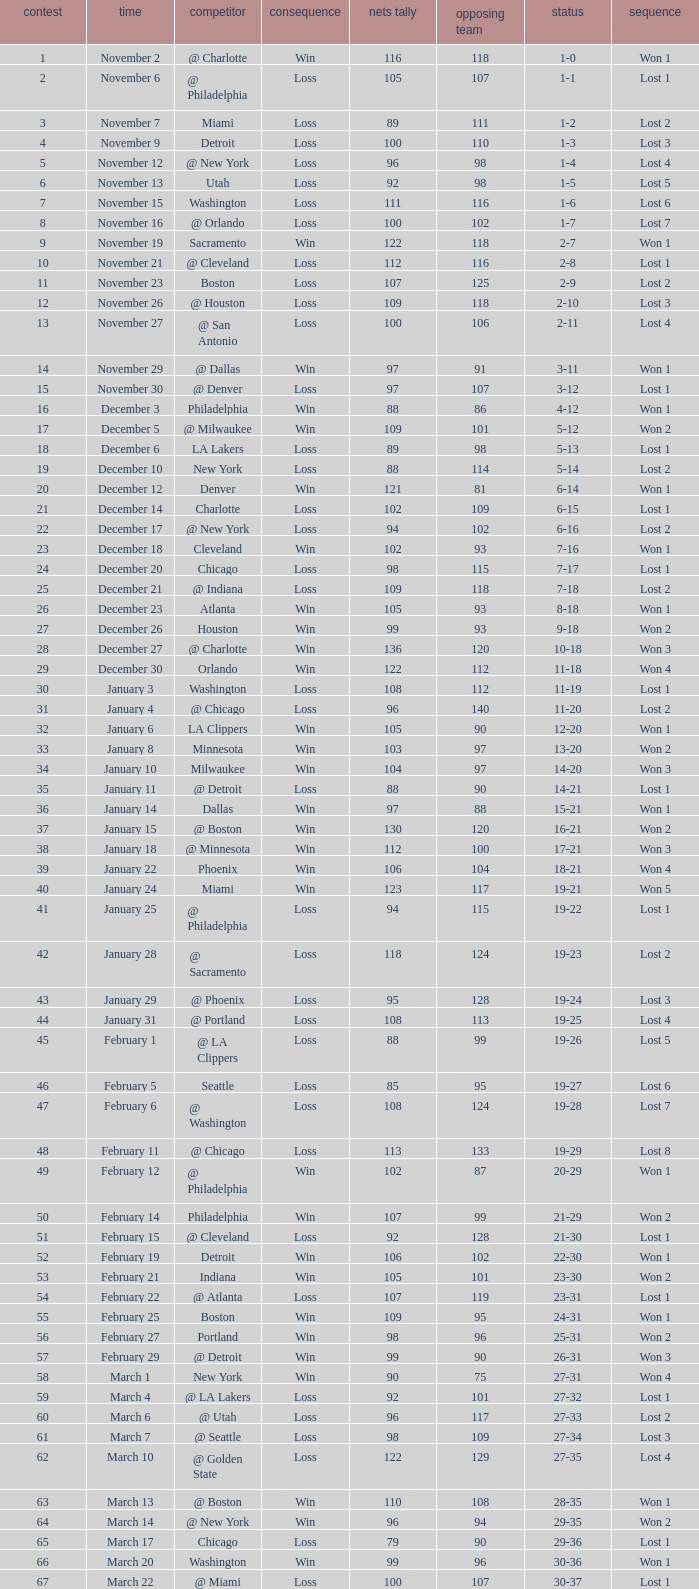How many games had fewer than 118 opponents and more than 109 net points with an opponent of Washington? 1.0. 